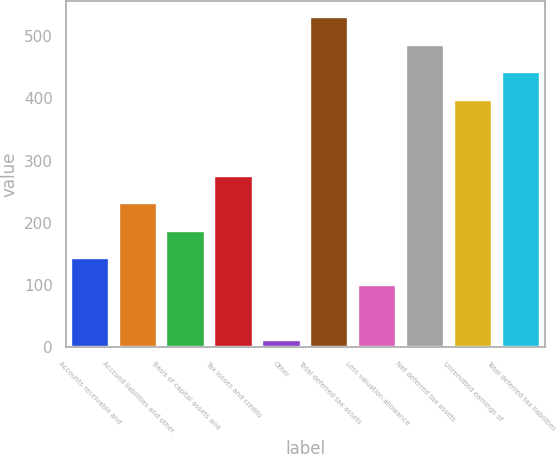Convert chart to OTSL. <chart><loc_0><loc_0><loc_500><loc_500><bar_chart><fcel>Accounts receivable and<fcel>Accrued liabilities and other<fcel>Basis of capital assets and<fcel>Tax losses and credits<fcel>Other<fcel>Total deferred tax assets<fcel>Less valuation allowance<fcel>Net deferred tax assets<fcel>Unremitted earnings of<fcel>Total deferred tax liabilities<nl><fcel>143.3<fcel>231.5<fcel>187.4<fcel>275.6<fcel>11<fcel>530.3<fcel>99.2<fcel>486.2<fcel>398<fcel>442.1<nl></chart> 